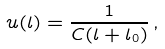Convert formula to latex. <formula><loc_0><loc_0><loc_500><loc_500>u ( l ) = \frac { 1 } { C ( l + l _ { 0 } ) } \, ,</formula> 